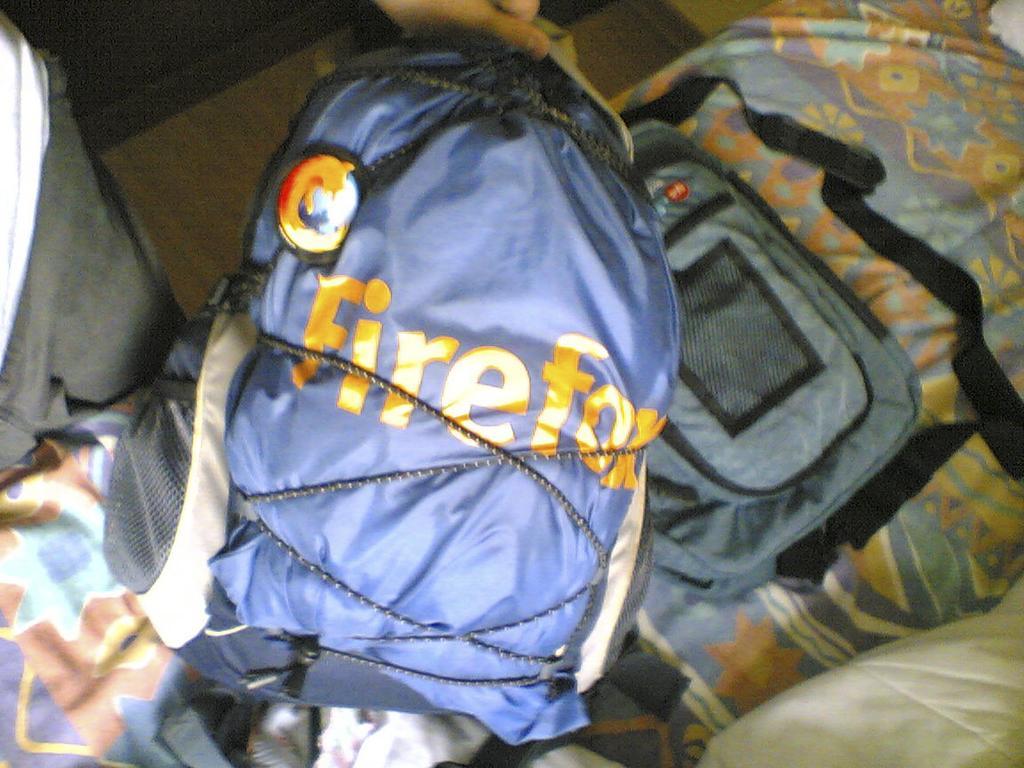Describe this image in one or two sentences. In this picture there is a blue bag on a bed. The man is holding the bag on the bag it is written as a fire fox. 